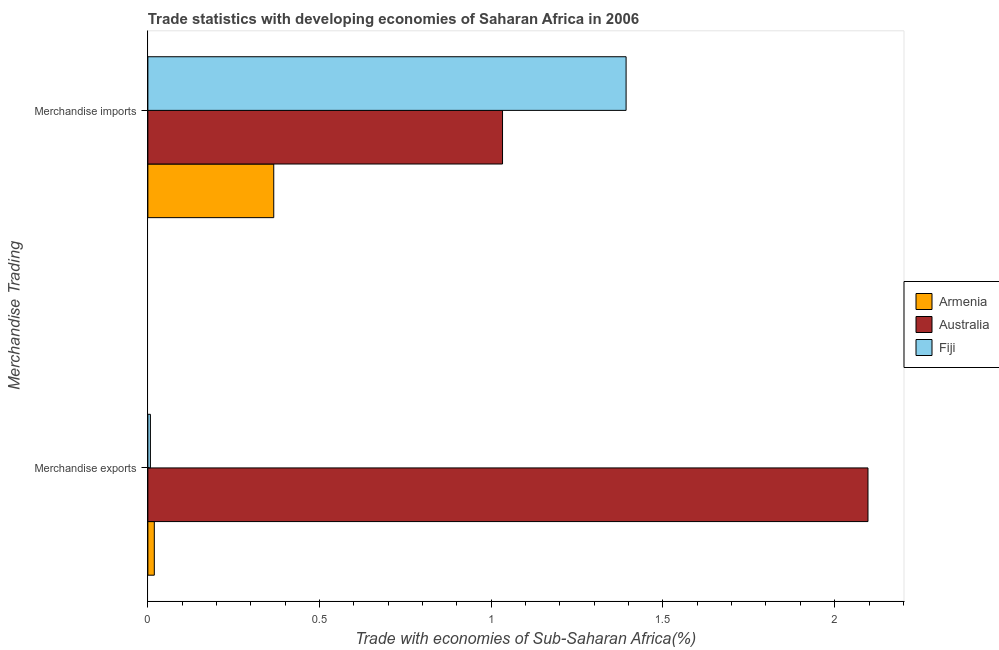How many groups of bars are there?
Provide a short and direct response. 2. Are the number of bars on each tick of the Y-axis equal?
Your response must be concise. Yes. How many bars are there on the 1st tick from the top?
Make the answer very short. 3. What is the label of the 2nd group of bars from the top?
Provide a short and direct response. Merchandise exports. What is the merchandise imports in Armenia?
Your response must be concise. 0.37. Across all countries, what is the maximum merchandise exports?
Your answer should be very brief. 2.1. Across all countries, what is the minimum merchandise imports?
Provide a short and direct response. 0.37. In which country was the merchandise imports maximum?
Offer a terse response. Fiji. In which country was the merchandise imports minimum?
Your answer should be very brief. Armenia. What is the total merchandise imports in the graph?
Ensure brevity in your answer.  2.79. What is the difference between the merchandise exports in Armenia and that in Australia?
Your answer should be very brief. -2.08. What is the difference between the merchandise exports in Fiji and the merchandise imports in Armenia?
Offer a terse response. -0.36. What is the average merchandise exports per country?
Give a very brief answer. 0.71. What is the difference between the merchandise exports and merchandise imports in Australia?
Your answer should be very brief. 1.06. In how many countries, is the merchandise imports greater than 1.7 %?
Keep it short and to the point. 0. What is the ratio of the merchandise imports in Armenia to that in Australia?
Ensure brevity in your answer.  0.35. What does the 3rd bar from the top in Merchandise imports represents?
Provide a succinct answer. Armenia. What does the 2nd bar from the bottom in Merchandise imports represents?
Ensure brevity in your answer.  Australia. How many bars are there?
Offer a very short reply. 6. How many countries are there in the graph?
Give a very brief answer. 3. Does the graph contain grids?
Make the answer very short. No. Where does the legend appear in the graph?
Keep it short and to the point. Center right. How many legend labels are there?
Your response must be concise. 3. How are the legend labels stacked?
Your answer should be very brief. Vertical. What is the title of the graph?
Give a very brief answer. Trade statistics with developing economies of Saharan Africa in 2006. What is the label or title of the X-axis?
Make the answer very short. Trade with economies of Sub-Saharan Africa(%). What is the label or title of the Y-axis?
Provide a short and direct response. Merchandise Trading. What is the Trade with economies of Sub-Saharan Africa(%) of Armenia in Merchandise exports?
Offer a very short reply. 0.02. What is the Trade with economies of Sub-Saharan Africa(%) of Australia in Merchandise exports?
Your answer should be compact. 2.1. What is the Trade with economies of Sub-Saharan Africa(%) of Fiji in Merchandise exports?
Your answer should be compact. 0.01. What is the Trade with economies of Sub-Saharan Africa(%) in Armenia in Merchandise imports?
Make the answer very short. 0.37. What is the Trade with economies of Sub-Saharan Africa(%) of Australia in Merchandise imports?
Make the answer very short. 1.03. What is the Trade with economies of Sub-Saharan Africa(%) in Fiji in Merchandise imports?
Provide a short and direct response. 1.39. Across all Merchandise Trading, what is the maximum Trade with economies of Sub-Saharan Africa(%) in Armenia?
Keep it short and to the point. 0.37. Across all Merchandise Trading, what is the maximum Trade with economies of Sub-Saharan Africa(%) of Australia?
Offer a terse response. 2.1. Across all Merchandise Trading, what is the maximum Trade with economies of Sub-Saharan Africa(%) in Fiji?
Your response must be concise. 1.39. Across all Merchandise Trading, what is the minimum Trade with economies of Sub-Saharan Africa(%) of Armenia?
Your answer should be very brief. 0.02. Across all Merchandise Trading, what is the minimum Trade with economies of Sub-Saharan Africa(%) of Australia?
Give a very brief answer. 1.03. Across all Merchandise Trading, what is the minimum Trade with economies of Sub-Saharan Africa(%) of Fiji?
Your response must be concise. 0.01. What is the total Trade with economies of Sub-Saharan Africa(%) in Armenia in the graph?
Keep it short and to the point. 0.39. What is the total Trade with economies of Sub-Saharan Africa(%) of Australia in the graph?
Provide a short and direct response. 3.13. What is the total Trade with economies of Sub-Saharan Africa(%) in Fiji in the graph?
Your answer should be very brief. 1.4. What is the difference between the Trade with economies of Sub-Saharan Africa(%) in Armenia in Merchandise exports and that in Merchandise imports?
Your response must be concise. -0.35. What is the difference between the Trade with economies of Sub-Saharan Africa(%) of Australia in Merchandise exports and that in Merchandise imports?
Provide a succinct answer. 1.06. What is the difference between the Trade with economies of Sub-Saharan Africa(%) in Fiji in Merchandise exports and that in Merchandise imports?
Ensure brevity in your answer.  -1.39. What is the difference between the Trade with economies of Sub-Saharan Africa(%) of Armenia in Merchandise exports and the Trade with economies of Sub-Saharan Africa(%) of Australia in Merchandise imports?
Your answer should be very brief. -1.01. What is the difference between the Trade with economies of Sub-Saharan Africa(%) in Armenia in Merchandise exports and the Trade with economies of Sub-Saharan Africa(%) in Fiji in Merchandise imports?
Offer a very short reply. -1.37. What is the difference between the Trade with economies of Sub-Saharan Africa(%) in Australia in Merchandise exports and the Trade with economies of Sub-Saharan Africa(%) in Fiji in Merchandise imports?
Offer a very short reply. 0.7. What is the average Trade with economies of Sub-Saharan Africa(%) of Armenia per Merchandise Trading?
Offer a terse response. 0.19. What is the average Trade with economies of Sub-Saharan Africa(%) in Australia per Merchandise Trading?
Ensure brevity in your answer.  1.56. What is the average Trade with economies of Sub-Saharan Africa(%) of Fiji per Merchandise Trading?
Provide a succinct answer. 0.7. What is the difference between the Trade with economies of Sub-Saharan Africa(%) in Armenia and Trade with economies of Sub-Saharan Africa(%) in Australia in Merchandise exports?
Provide a short and direct response. -2.08. What is the difference between the Trade with economies of Sub-Saharan Africa(%) in Armenia and Trade with economies of Sub-Saharan Africa(%) in Fiji in Merchandise exports?
Provide a short and direct response. 0.01. What is the difference between the Trade with economies of Sub-Saharan Africa(%) of Australia and Trade with economies of Sub-Saharan Africa(%) of Fiji in Merchandise exports?
Offer a very short reply. 2.09. What is the difference between the Trade with economies of Sub-Saharan Africa(%) of Armenia and Trade with economies of Sub-Saharan Africa(%) of Australia in Merchandise imports?
Provide a short and direct response. -0.67. What is the difference between the Trade with economies of Sub-Saharan Africa(%) in Armenia and Trade with economies of Sub-Saharan Africa(%) in Fiji in Merchandise imports?
Keep it short and to the point. -1.03. What is the difference between the Trade with economies of Sub-Saharan Africa(%) in Australia and Trade with economies of Sub-Saharan Africa(%) in Fiji in Merchandise imports?
Your answer should be compact. -0.36. What is the ratio of the Trade with economies of Sub-Saharan Africa(%) in Armenia in Merchandise exports to that in Merchandise imports?
Offer a very short reply. 0.05. What is the ratio of the Trade with economies of Sub-Saharan Africa(%) of Australia in Merchandise exports to that in Merchandise imports?
Your answer should be very brief. 2.03. What is the ratio of the Trade with economies of Sub-Saharan Africa(%) in Fiji in Merchandise exports to that in Merchandise imports?
Offer a terse response. 0.01. What is the difference between the highest and the second highest Trade with economies of Sub-Saharan Africa(%) in Armenia?
Give a very brief answer. 0.35. What is the difference between the highest and the second highest Trade with economies of Sub-Saharan Africa(%) in Australia?
Give a very brief answer. 1.06. What is the difference between the highest and the second highest Trade with economies of Sub-Saharan Africa(%) in Fiji?
Your answer should be very brief. 1.39. What is the difference between the highest and the lowest Trade with economies of Sub-Saharan Africa(%) in Armenia?
Give a very brief answer. 0.35. What is the difference between the highest and the lowest Trade with economies of Sub-Saharan Africa(%) of Australia?
Keep it short and to the point. 1.06. What is the difference between the highest and the lowest Trade with economies of Sub-Saharan Africa(%) in Fiji?
Your response must be concise. 1.39. 